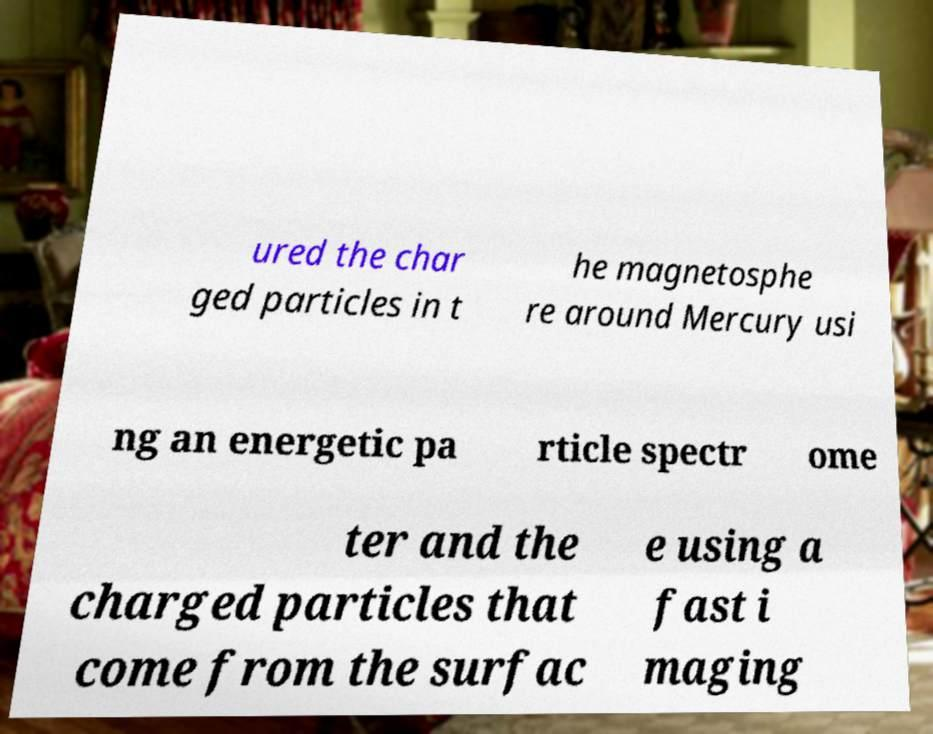I need the written content from this picture converted into text. Can you do that? ured the char ged particles in t he magnetosphe re around Mercury usi ng an energetic pa rticle spectr ome ter and the charged particles that come from the surfac e using a fast i maging 